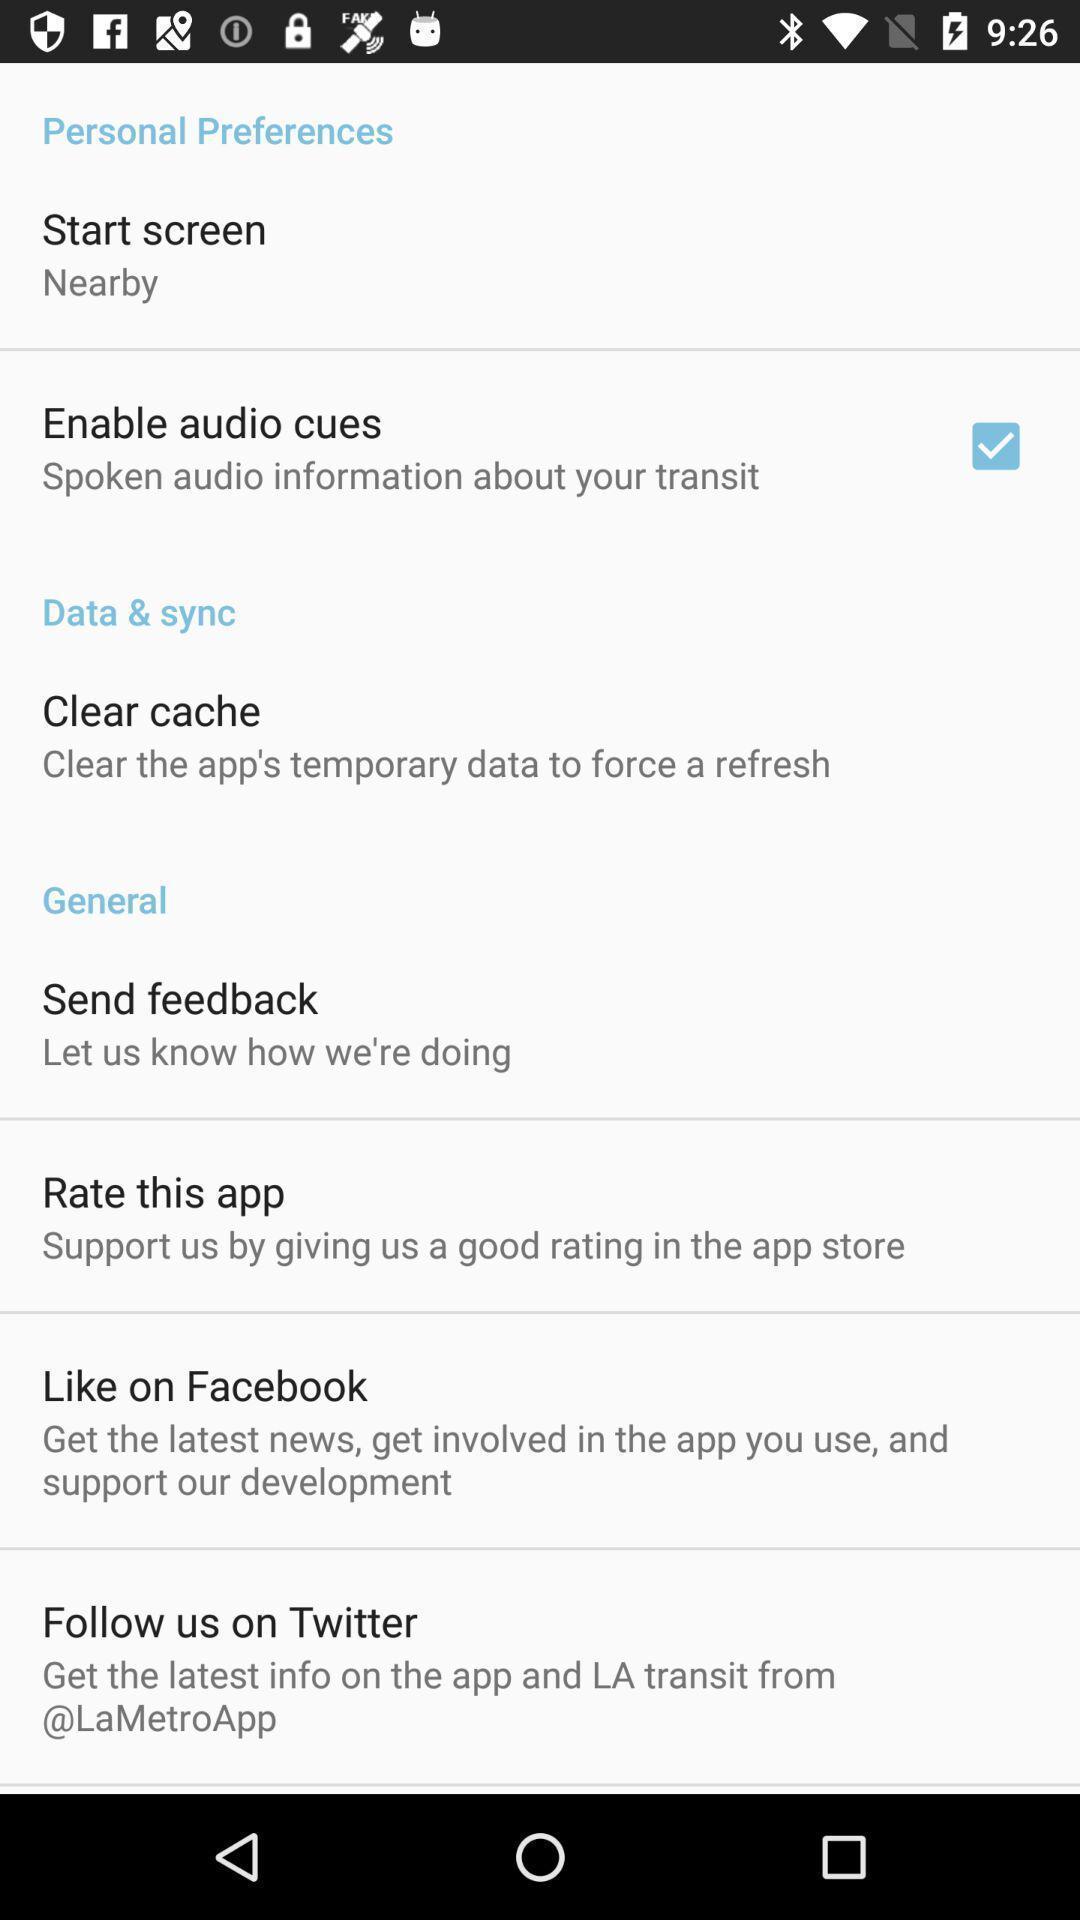Explain what's happening in this screen capture. Personal preferences data and general options displayed. 